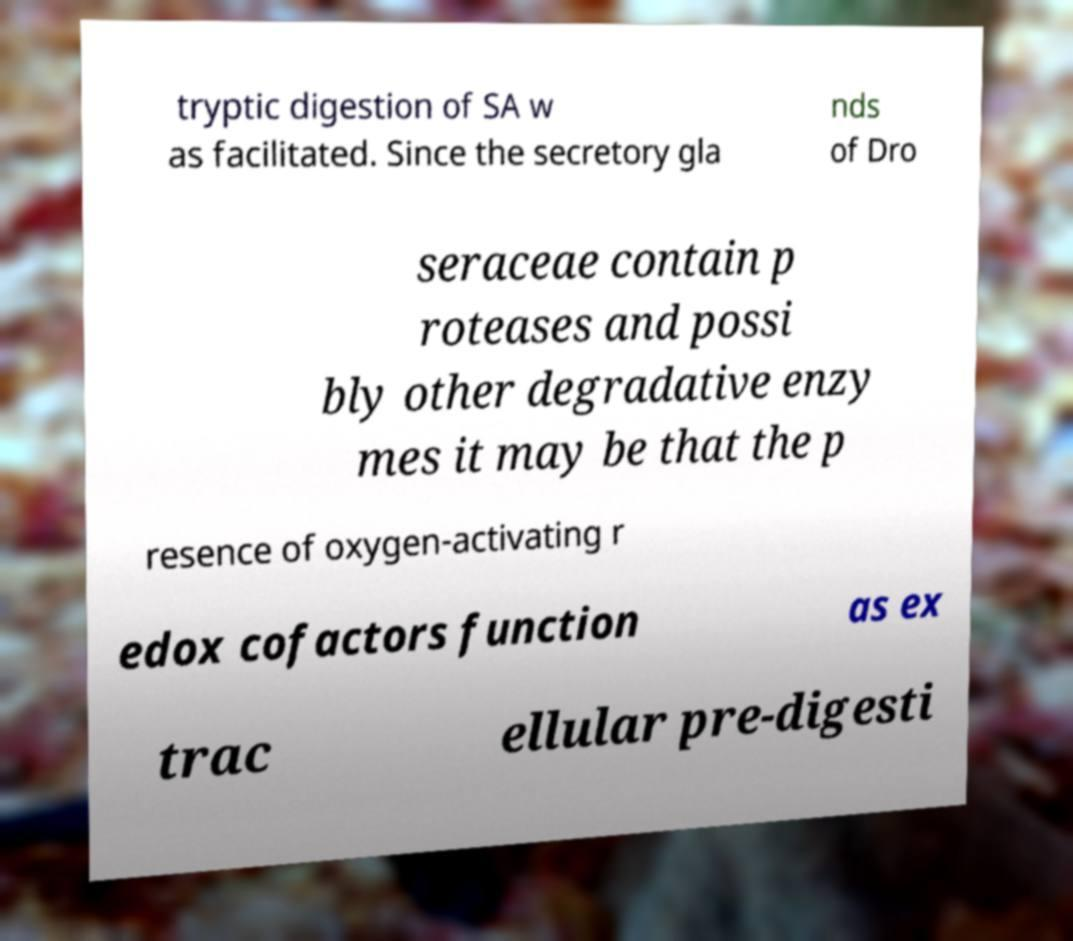Could you assist in decoding the text presented in this image and type it out clearly? tryptic digestion of SA w as facilitated. Since the secretory gla nds of Dro seraceae contain p roteases and possi bly other degradative enzy mes it may be that the p resence of oxygen-activating r edox cofactors function as ex trac ellular pre-digesti 